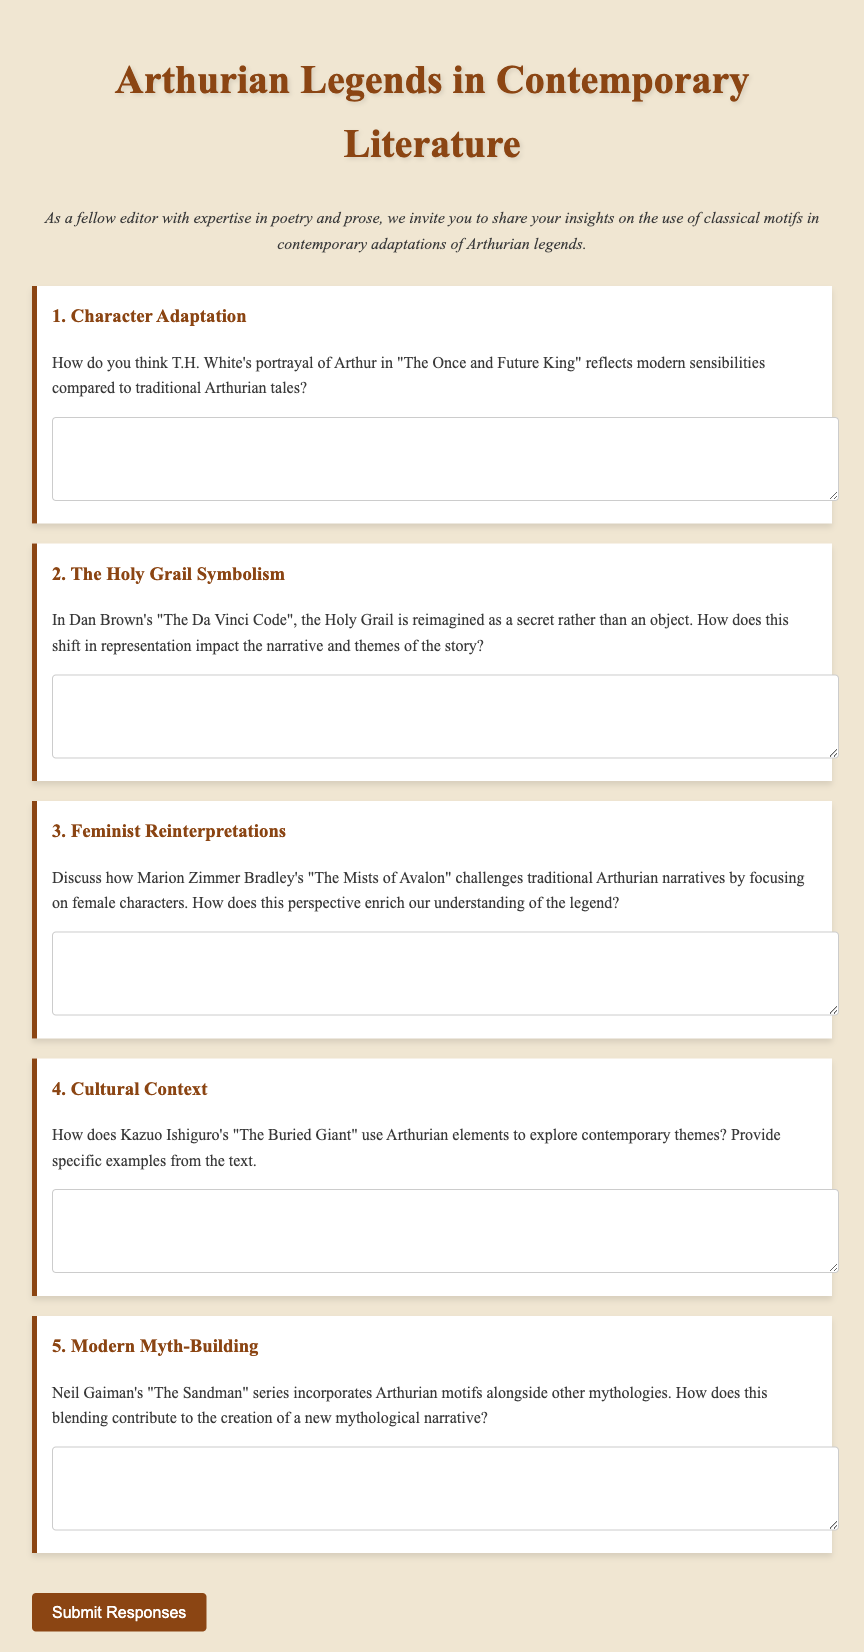What is the title of the document? The title of the document is displayed prominently in the header.
Answer: Arthurian Legends in Contemporary Literature Questionnaire How many main questions are there in the questionnaire? The document contains five main questions regarding Arthurian legends.
Answer: 5 What narrative does Dan Brown's work relate to? The specific work mentioned in relation to the Holy Grail is included in the second question.
Answer: The Da Vinci Code Which author's work is specifically mentioned in the third question? The document explicitly states the author's name in the context of challenging traditional narratives.
Answer: Marion Zimmer Bradley What kind of motifs does Neil Gaiman incorporate in his series? The type of motifs mentioned in the fifth question relates to various mythologies.
Answer: Arthurian motifs What is the main theme explored in Kazuo Ishiguro's "The Buried Giant"? The document indicates the use of Arthurian elements to highlight contemporary themes.
Answer: Contemporary themes 